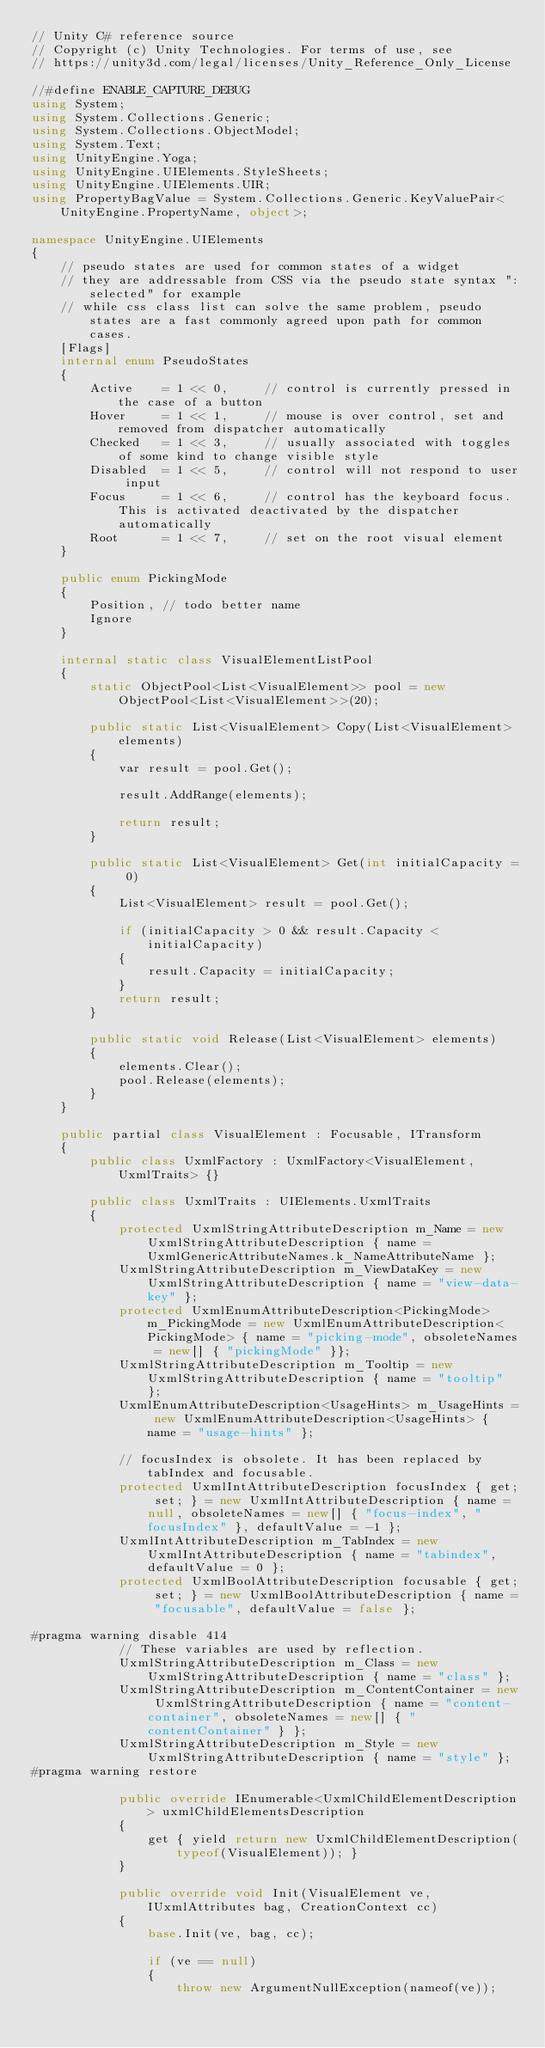Convert code to text. <code><loc_0><loc_0><loc_500><loc_500><_C#_>// Unity C# reference source
// Copyright (c) Unity Technologies. For terms of use, see
// https://unity3d.com/legal/licenses/Unity_Reference_Only_License

//#define ENABLE_CAPTURE_DEBUG
using System;
using System.Collections.Generic;
using System.Collections.ObjectModel;
using System.Text;
using UnityEngine.Yoga;
using UnityEngine.UIElements.StyleSheets;
using UnityEngine.UIElements.UIR;
using PropertyBagValue = System.Collections.Generic.KeyValuePair<UnityEngine.PropertyName, object>;

namespace UnityEngine.UIElements
{
    // pseudo states are used for common states of a widget
    // they are addressable from CSS via the pseudo state syntax ":selected" for example
    // while css class list can solve the same problem, pseudo states are a fast commonly agreed upon path for common cases.
    [Flags]
    internal enum PseudoStates
    {
        Active    = 1 << 0,     // control is currently pressed in the case of a button
        Hover     = 1 << 1,     // mouse is over control, set and removed from dispatcher automatically
        Checked   = 1 << 3,     // usually associated with toggles of some kind to change visible style
        Disabled  = 1 << 5,     // control will not respond to user input
        Focus     = 1 << 6,     // control has the keyboard focus. This is activated deactivated by the dispatcher automatically
        Root      = 1 << 7,     // set on the root visual element
    }

    public enum PickingMode
    {
        Position, // todo better name
        Ignore
    }

    internal static class VisualElementListPool
    {
        static ObjectPool<List<VisualElement>> pool = new ObjectPool<List<VisualElement>>(20);

        public static List<VisualElement> Copy(List<VisualElement> elements)
        {
            var result = pool.Get();

            result.AddRange(elements);

            return result;
        }

        public static List<VisualElement> Get(int initialCapacity = 0)
        {
            List<VisualElement> result = pool.Get();

            if (initialCapacity > 0 && result.Capacity < initialCapacity)
            {
                result.Capacity = initialCapacity;
            }
            return result;
        }

        public static void Release(List<VisualElement> elements)
        {
            elements.Clear();
            pool.Release(elements);
        }
    }

    public partial class VisualElement : Focusable, ITransform
    {
        public class UxmlFactory : UxmlFactory<VisualElement, UxmlTraits> {}

        public class UxmlTraits : UIElements.UxmlTraits
        {
            protected UxmlStringAttributeDescription m_Name = new UxmlStringAttributeDescription { name = UxmlGenericAttributeNames.k_NameAttributeName };
            UxmlStringAttributeDescription m_ViewDataKey = new UxmlStringAttributeDescription { name = "view-data-key" };
            protected UxmlEnumAttributeDescription<PickingMode> m_PickingMode = new UxmlEnumAttributeDescription<PickingMode> { name = "picking-mode", obsoleteNames = new[] { "pickingMode" }};
            UxmlStringAttributeDescription m_Tooltip = new UxmlStringAttributeDescription { name = "tooltip" };
            UxmlEnumAttributeDescription<UsageHints> m_UsageHints = new UxmlEnumAttributeDescription<UsageHints> { name = "usage-hints" };

            // focusIndex is obsolete. It has been replaced by tabIndex and focusable.
            protected UxmlIntAttributeDescription focusIndex { get; set; } = new UxmlIntAttributeDescription { name = null, obsoleteNames = new[] { "focus-index", "focusIndex" }, defaultValue = -1 };
            UxmlIntAttributeDescription m_TabIndex = new UxmlIntAttributeDescription { name = "tabindex", defaultValue = 0 };
            protected UxmlBoolAttributeDescription focusable { get; set; } = new UxmlBoolAttributeDescription { name = "focusable", defaultValue = false };

#pragma warning disable 414
            // These variables are used by reflection.
            UxmlStringAttributeDescription m_Class = new UxmlStringAttributeDescription { name = "class" };
            UxmlStringAttributeDescription m_ContentContainer = new UxmlStringAttributeDescription { name = "content-container", obsoleteNames = new[] { "contentContainer" } };
            UxmlStringAttributeDescription m_Style = new UxmlStringAttributeDescription { name = "style" };
#pragma warning restore

            public override IEnumerable<UxmlChildElementDescription> uxmlChildElementsDescription
            {
                get { yield return new UxmlChildElementDescription(typeof(VisualElement)); }
            }

            public override void Init(VisualElement ve, IUxmlAttributes bag, CreationContext cc)
            {
                base.Init(ve, bag, cc);

                if (ve == null)
                {
                    throw new ArgumentNullException(nameof(ve));</code> 